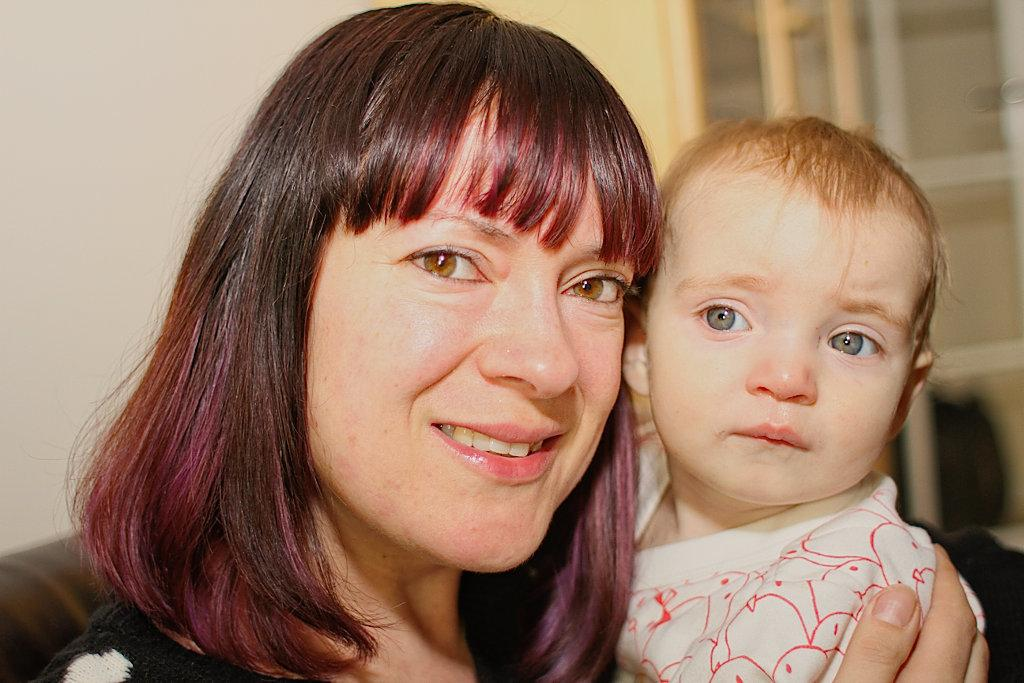Who is the main subject in the image? There is a woman in the image. What is the woman doing in the image? The woman is holding a baby. What can be seen in the background of the image? There is a wall and a window in the background of the image. How many teeth can be seen in the woman's hand in the image? There are no teeth visible in the woman's hand in the image. 